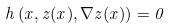Convert formula to latex. <formula><loc_0><loc_0><loc_500><loc_500>h \left ( x , z ( x ) , \nabla z ( x ) \right ) = 0</formula> 